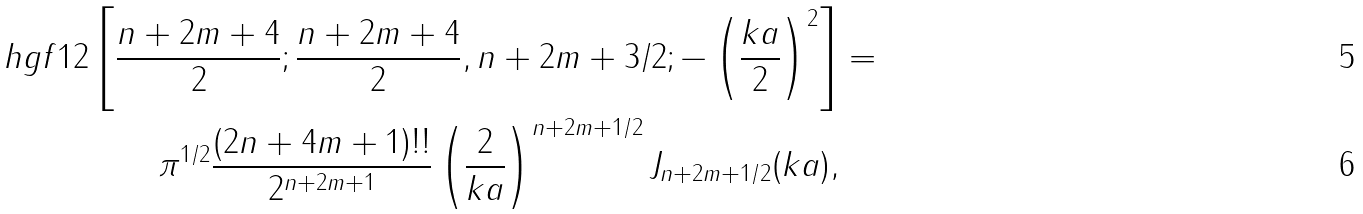<formula> <loc_0><loc_0><loc_500><loc_500>\ h g f { 1 } { 2 } \left [ \frac { n + 2 m + 4 } { 2 } ; \frac { n + 2 m + 4 } { 2 } , n + 2 m + 3 / 2 ; - \left ( \frac { k a } { 2 } \right ) ^ { 2 } \right ] & = \\ \pi ^ { 1 / 2 } \frac { ( 2 n + 4 m + 1 ) ! ! } { 2 ^ { n + 2 m + 1 } } \left ( \frac { 2 } { k a } \right ) ^ { n + 2 m + 1 / 2 } J _ { n + 2 m + 1 / 2 } ( k a ) ,</formula> 